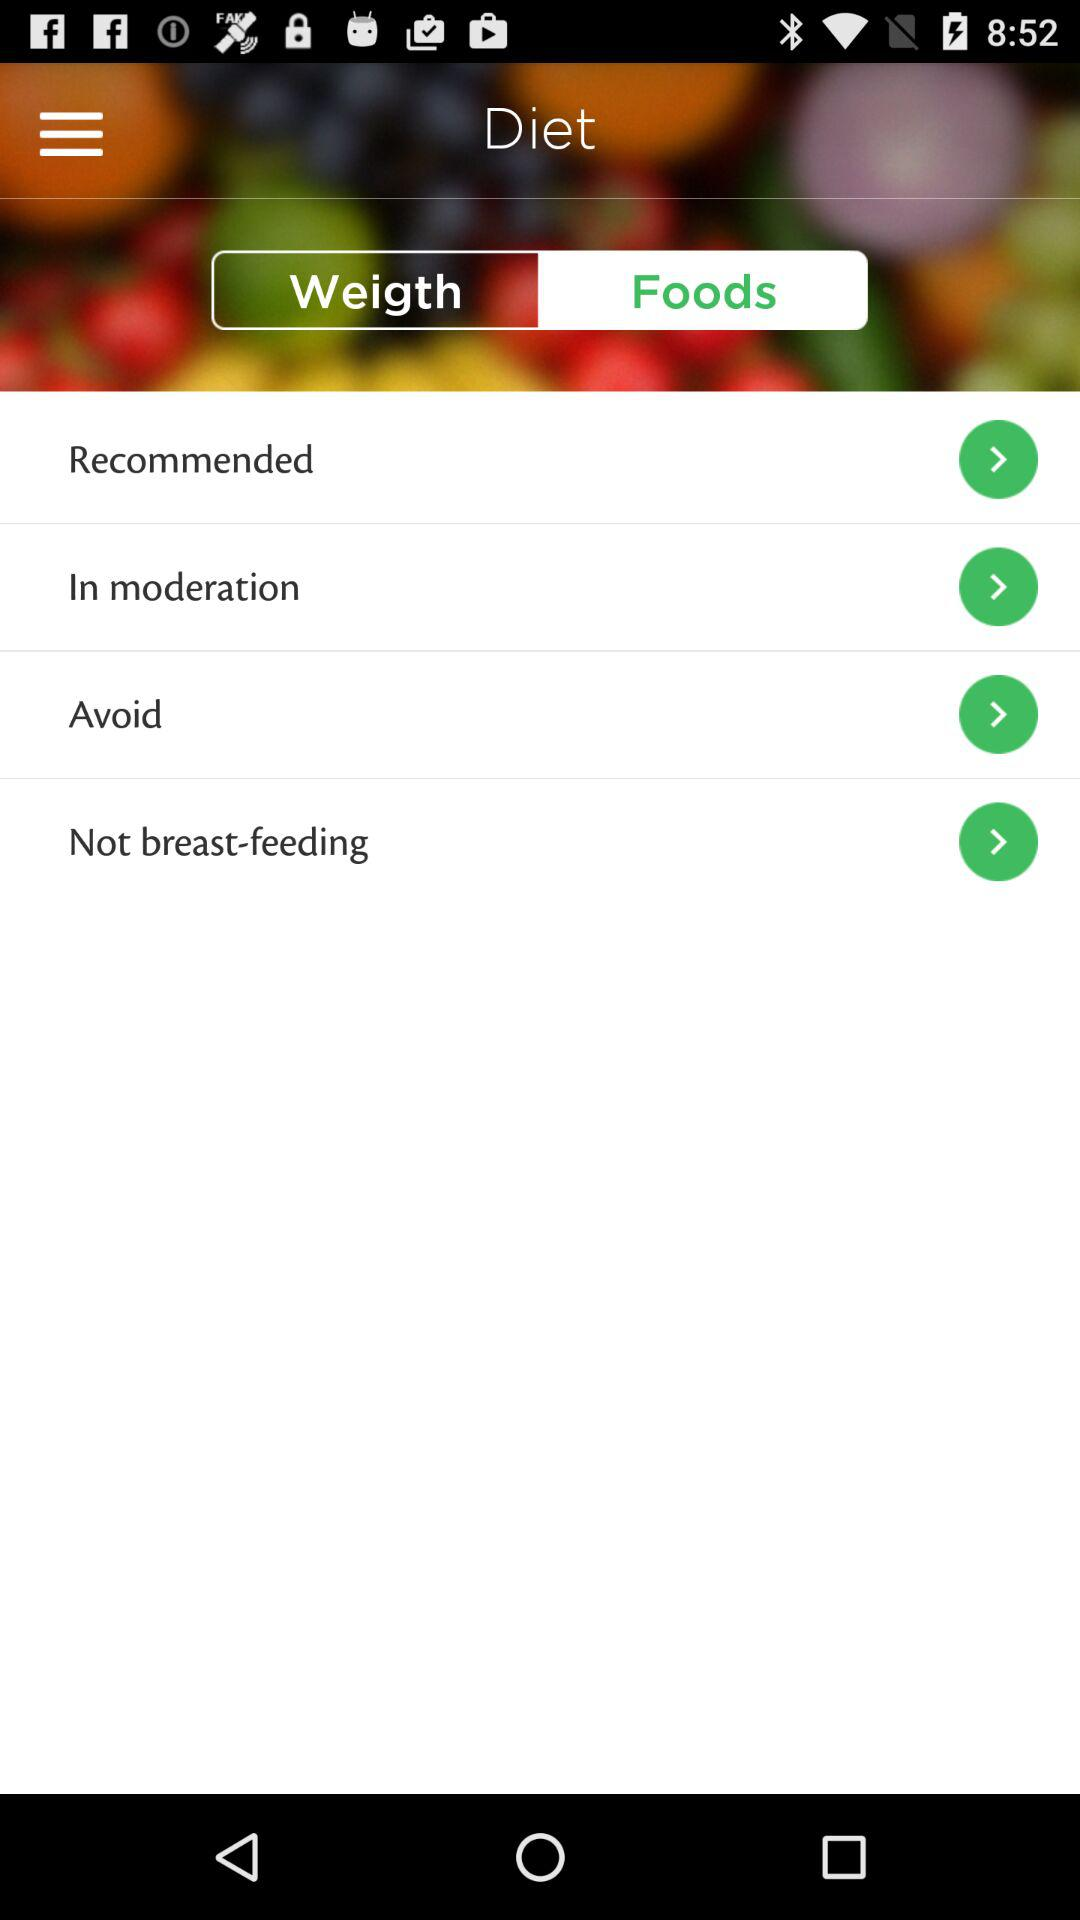Which tab is selected? The selected tab is "Foods". 